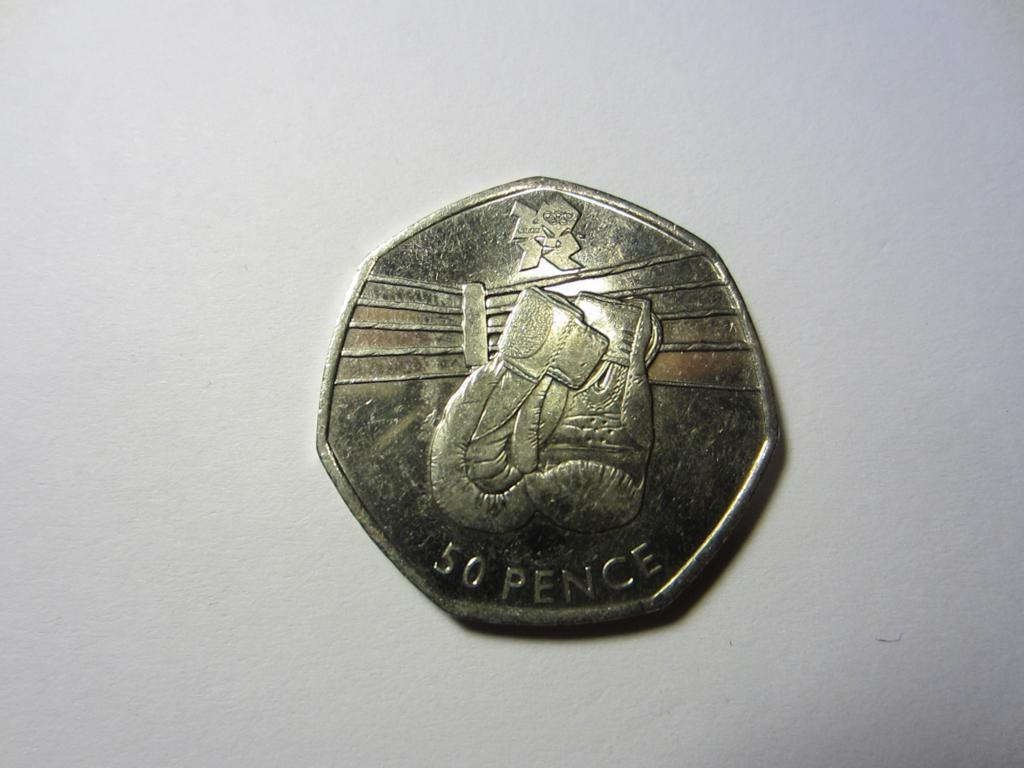What object is the main focus of the image? There is a coin in the image in the image. What can be seen on the coin? The coin has two numbers on it, a word, and a picture. What is the color of the surface the coin is placed on? The coin is on a white surface. Can you describe the bee that is buzzing around the coin in the image? There is no bee present in the image; it only features a coin on a white surface. Is there a snowy landscape visible in the image? No, there is no snow or snowy landscape visible in the image. 